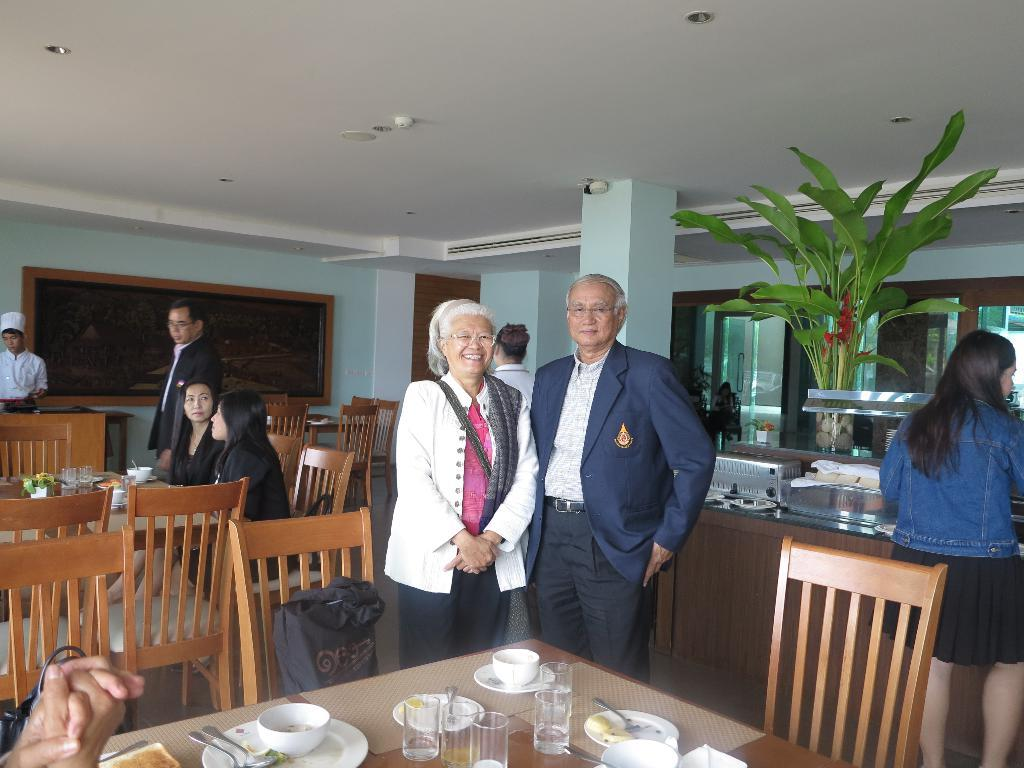What are the people in the image doing? There are people seated and standing in the image. Can you describe any objects in the image besides the people? Yes, there is a plant, glasses, and plates on the table in the image. What type of shock can be seen affecting the people in the image? There is no shock present in the image; the people are simply seated and standing. What suggestion can be made based on the presence of the plant in the image? There is no suggestion to be made based on the presence of the plant in the image; it is simply an object in the scene. 